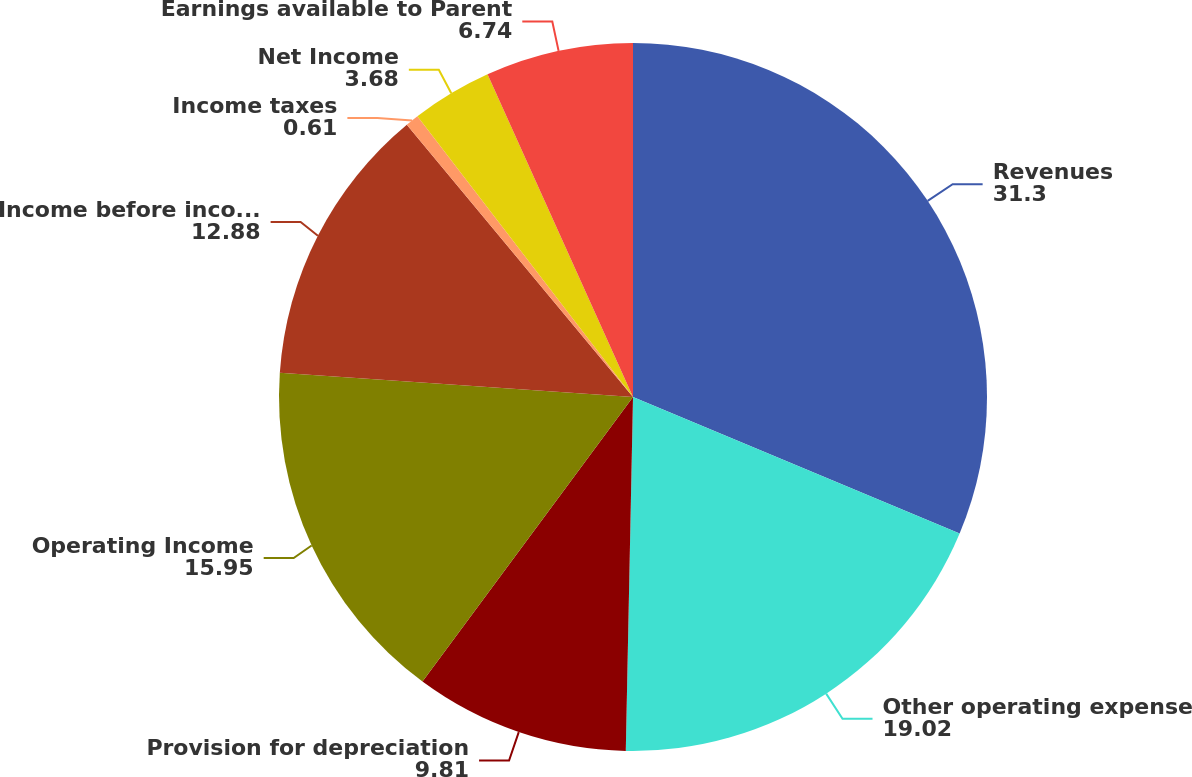Convert chart to OTSL. <chart><loc_0><loc_0><loc_500><loc_500><pie_chart><fcel>Revenues<fcel>Other operating expense<fcel>Provision for depreciation<fcel>Operating Income<fcel>Income before income taxes<fcel>Income taxes<fcel>Net Income<fcel>Earnings available to Parent<nl><fcel>31.3%<fcel>19.02%<fcel>9.81%<fcel>15.95%<fcel>12.88%<fcel>0.61%<fcel>3.68%<fcel>6.74%<nl></chart> 